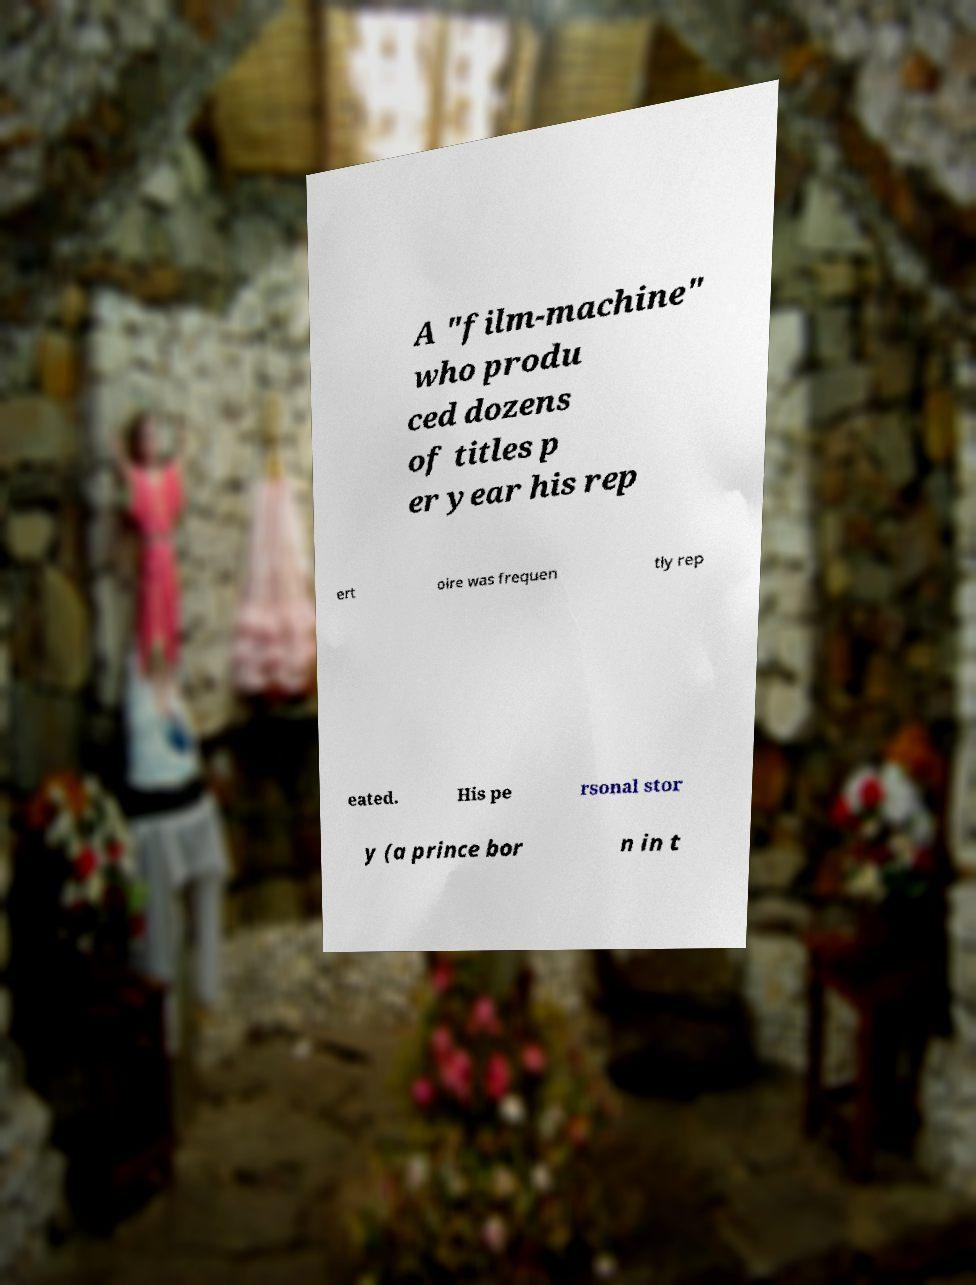There's text embedded in this image that I need extracted. Can you transcribe it verbatim? A "film-machine" who produ ced dozens of titles p er year his rep ert oire was frequen tly rep eated. His pe rsonal stor y (a prince bor n in t 